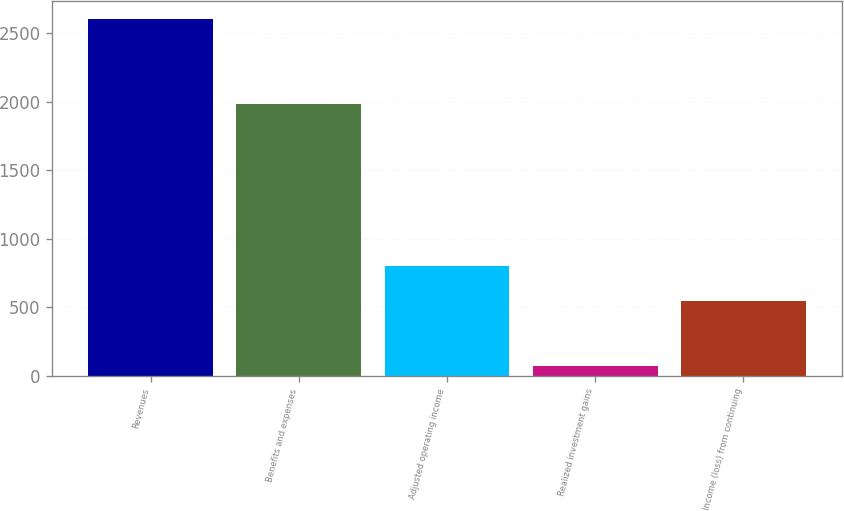Convert chart to OTSL. <chart><loc_0><loc_0><loc_500><loc_500><bar_chart><fcel>Revenues<fcel>Benefits and expenses<fcel>Adjusted operating income<fcel>Realized investment gains<fcel>Income (loss) from continuing<nl><fcel>2602<fcel>1980<fcel>800.8<fcel>74<fcel>548<nl></chart> 